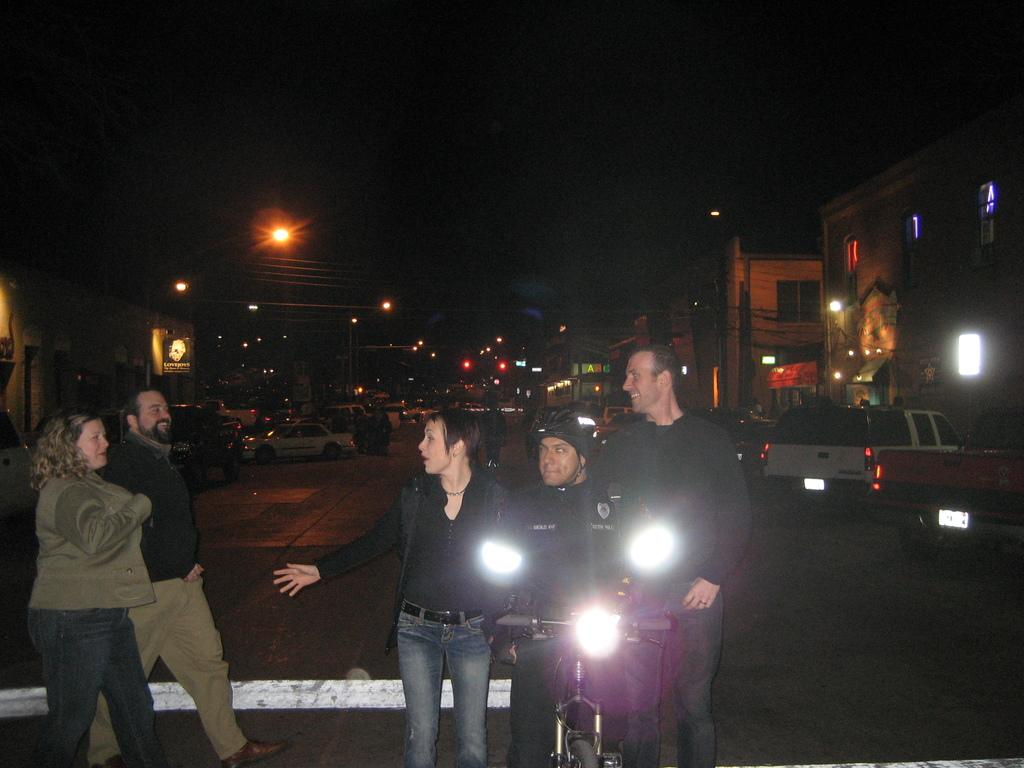What is happening on the road in the image? There are people and vehicles on the road in the image. What can be seen illuminating the road in the image? Street lights are visible in the image. What type of signage is present in the image? There are boards in the image. How many babies are crawling on the boards in the image? There are no babies present in the image; it features people, vehicles, street lights, and boards. What type of brush is being used to clean the vehicles in the image? There is no brush visible in the image, as it only shows people, vehicles, street lights, and boards. 